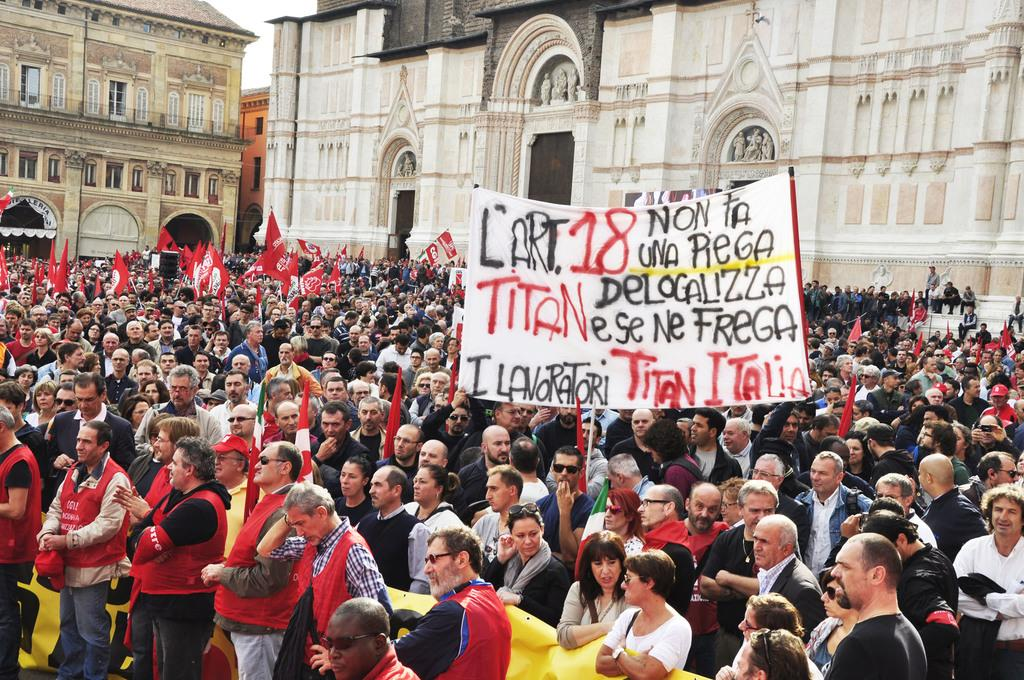What is happening in the image involving the group of people? The people in the image are standing and holding a banner. What can be seen in the background of the image? There are buildings visible in the background of the image. Can you describe the design of the tiger that is on top of the banner in the image? There is no tiger present in the image, nor is there any design on top of the banner. 